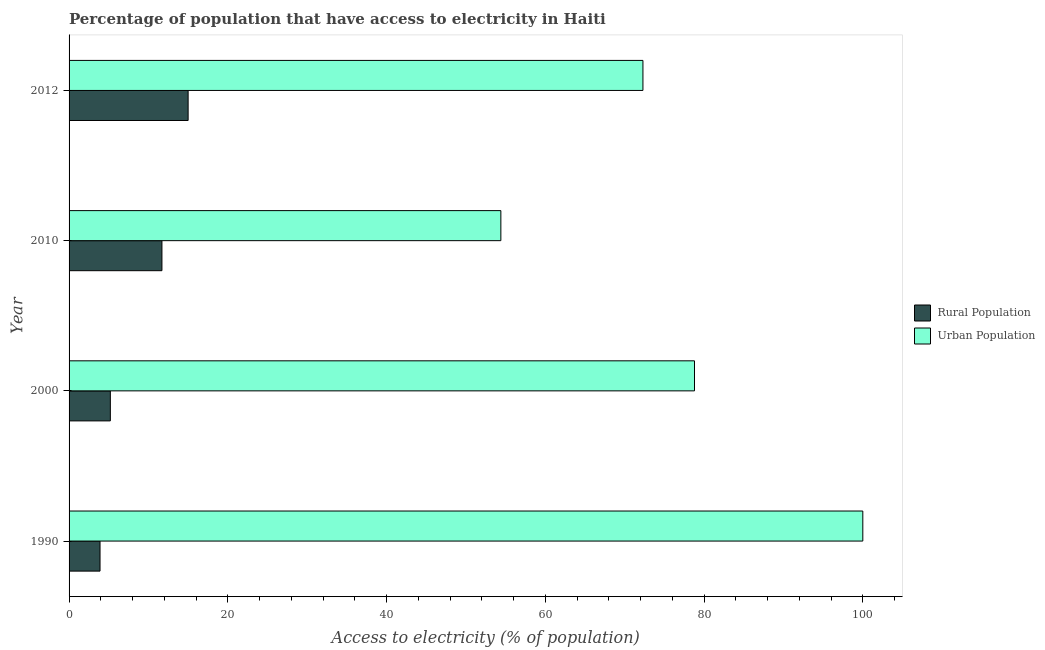How many different coloured bars are there?
Offer a terse response. 2. How many groups of bars are there?
Offer a terse response. 4. Are the number of bars on each tick of the Y-axis equal?
Give a very brief answer. Yes. How many bars are there on the 2nd tick from the top?
Offer a terse response. 2. What is the label of the 1st group of bars from the top?
Give a very brief answer. 2012. What is the percentage of urban population having access to electricity in 1990?
Keep it short and to the point. 100. Across all years, what is the minimum percentage of urban population having access to electricity?
Provide a succinct answer. 54.4. What is the total percentage of urban population having access to electricity in the graph?
Make the answer very short. 305.5. What is the difference between the percentage of rural population having access to electricity in 1990 and that in 2000?
Your answer should be very brief. -1.3. What is the difference between the percentage of urban population having access to electricity in 2000 and the percentage of rural population having access to electricity in 2012?
Offer a very short reply. 63.8. What is the average percentage of urban population having access to electricity per year?
Keep it short and to the point. 76.37. In the year 2012, what is the difference between the percentage of rural population having access to electricity and percentage of urban population having access to electricity?
Provide a short and direct response. -57.3. In how many years, is the percentage of rural population having access to electricity greater than 48 %?
Offer a very short reply. 0. What is the ratio of the percentage of rural population having access to electricity in 1990 to that in 2000?
Your response must be concise. 0.75. Is the difference between the percentage of urban population having access to electricity in 1990 and 2012 greater than the difference between the percentage of rural population having access to electricity in 1990 and 2012?
Make the answer very short. Yes. What is the difference between the highest and the lowest percentage of rural population having access to electricity?
Provide a short and direct response. 11.1. Is the sum of the percentage of rural population having access to electricity in 1990 and 2010 greater than the maximum percentage of urban population having access to electricity across all years?
Ensure brevity in your answer.  No. What does the 1st bar from the top in 2000 represents?
Provide a short and direct response. Urban Population. What does the 2nd bar from the bottom in 2012 represents?
Offer a very short reply. Urban Population. How many years are there in the graph?
Offer a very short reply. 4. Are the values on the major ticks of X-axis written in scientific E-notation?
Ensure brevity in your answer.  No. Does the graph contain grids?
Keep it short and to the point. No. How many legend labels are there?
Offer a very short reply. 2. How are the legend labels stacked?
Offer a terse response. Vertical. What is the title of the graph?
Ensure brevity in your answer.  Percentage of population that have access to electricity in Haiti. What is the label or title of the X-axis?
Provide a succinct answer. Access to electricity (% of population). What is the label or title of the Y-axis?
Your answer should be compact. Year. What is the Access to electricity (% of population) in Rural Population in 1990?
Provide a short and direct response. 3.9. What is the Access to electricity (% of population) in Rural Population in 2000?
Your answer should be compact. 5.2. What is the Access to electricity (% of population) of Urban Population in 2000?
Give a very brief answer. 78.8. What is the Access to electricity (% of population) of Rural Population in 2010?
Provide a short and direct response. 11.7. What is the Access to electricity (% of population) in Urban Population in 2010?
Provide a succinct answer. 54.4. What is the Access to electricity (% of population) of Urban Population in 2012?
Your answer should be very brief. 72.3. Across all years, what is the maximum Access to electricity (% of population) in Urban Population?
Offer a very short reply. 100. Across all years, what is the minimum Access to electricity (% of population) of Urban Population?
Offer a very short reply. 54.4. What is the total Access to electricity (% of population) of Rural Population in the graph?
Offer a terse response. 35.8. What is the total Access to electricity (% of population) of Urban Population in the graph?
Offer a very short reply. 305.5. What is the difference between the Access to electricity (% of population) in Rural Population in 1990 and that in 2000?
Offer a very short reply. -1.3. What is the difference between the Access to electricity (% of population) of Urban Population in 1990 and that in 2000?
Ensure brevity in your answer.  21.2. What is the difference between the Access to electricity (% of population) in Urban Population in 1990 and that in 2010?
Give a very brief answer. 45.6. What is the difference between the Access to electricity (% of population) in Rural Population in 1990 and that in 2012?
Offer a very short reply. -11.1. What is the difference between the Access to electricity (% of population) in Urban Population in 1990 and that in 2012?
Offer a very short reply. 27.7. What is the difference between the Access to electricity (% of population) of Urban Population in 2000 and that in 2010?
Your response must be concise. 24.39. What is the difference between the Access to electricity (% of population) in Rural Population in 2000 and that in 2012?
Provide a short and direct response. -9.8. What is the difference between the Access to electricity (% of population) in Urban Population in 2000 and that in 2012?
Your answer should be very brief. 6.5. What is the difference between the Access to electricity (% of population) in Rural Population in 2010 and that in 2012?
Your answer should be compact. -3.3. What is the difference between the Access to electricity (% of population) of Urban Population in 2010 and that in 2012?
Provide a succinct answer. -17.9. What is the difference between the Access to electricity (% of population) in Rural Population in 1990 and the Access to electricity (% of population) in Urban Population in 2000?
Ensure brevity in your answer.  -74.9. What is the difference between the Access to electricity (% of population) in Rural Population in 1990 and the Access to electricity (% of population) in Urban Population in 2010?
Your answer should be compact. -50.5. What is the difference between the Access to electricity (% of population) in Rural Population in 1990 and the Access to electricity (% of population) in Urban Population in 2012?
Ensure brevity in your answer.  -68.4. What is the difference between the Access to electricity (% of population) in Rural Population in 2000 and the Access to electricity (% of population) in Urban Population in 2010?
Provide a succinct answer. -49.2. What is the difference between the Access to electricity (% of population) in Rural Population in 2000 and the Access to electricity (% of population) in Urban Population in 2012?
Your response must be concise. -67.1. What is the difference between the Access to electricity (% of population) of Rural Population in 2010 and the Access to electricity (% of population) of Urban Population in 2012?
Provide a short and direct response. -60.6. What is the average Access to electricity (% of population) in Rural Population per year?
Your answer should be very brief. 8.95. What is the average Access to electricity (% of population) in Urban Population per year?
Keep it short and to the point. 76.37. In the year 1990, what is the difference between the Access to electricity (% of population) in Rural Population and Access to electricity (% of population) in Urban Population?
Ensure brevity in your answer.  -96.1. In the year 2000, what is the difference between the Access to electricity (% of population) of Rural Population and Access to electricity (% of population) of Urban Population?
Offer a very short reply. -73.6. In the year 2010, what is the difference between the Access to electricity (% of population) in Rural Population and Access to electricity (% of population) in Urban Population?
Give a very brief answer. -42.7. In the year 2012, what is the difference between the Access to electricity (% of population) of Rural Population and Access to electricity (% of population) of Urban Population?
Your answer should be very brief. -57.3. What is the ratio of the Access to electricity (% of population) in Rural Population in 1990 to that in 2000?
Offer a very short reply. 0.75. What is the ratio of the Access to electricity (% of population) of Urban Population in 1990 to that in 2000?
Provide a short and direct response. 1.27. What is the ratio of the Access to electricity (% of population) of Rural Population in 1990 to that in 2010?
Keep it short and to the point. 0.33. What is the ratio of the Access to electricity (% of population) in Urban Population in 1990 to that in 2010?
Ensure brevity in your answer.  1.84. What is the ratio of the Access to electricity (% of population) in Rural Population in 1990 to that in 2012?
Offer a very short reply. 0.26. What is the ratio of the Access to electricity (% of population) in Urban Population in 1990 to that in 2012?
Your answer should be very brief. 1.38. What is the ratio of the Access to electricity (% of population) in Rural Population in 2000 to that in 2010?
Keep it short and to the point. 0.44. What is the ratio of the Access to electricity (% of population) in Urban Population in 2000 to that in 2010?
Give a very brief answer. 1.45. What is the ratio of the Access to electricity (% of population) in Rural Population in 2000 to that in 2012?
Offer a terse response. 0.35. What is the ratio of the Access to electricity (% of population) of Urban Population in 2000 to that in 2012?
Your answer should be compact. 1.09. What is the ratio of the Access to electricity (% of population) of Rural Population in 2010 to that in 2012?
Give a very brief answer. 0.78. What is the ratio of the Access to electricity (% of population) in Urban Population in 2010 to that in 2012?
Provide a succinct answer. 0.75. What is the difference between the highest and the second highest Access to electricity (% of population) in Urban Population?
Ensure brevity in your answer.  21.2. What is the difference between the highest and the lowest Access to electricity (% of population) in Urban Population?
Your answer should be very brief. 45.6. 